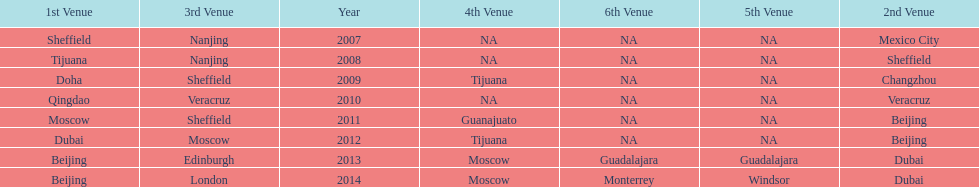What years had the most venues? 2013, 2014. 